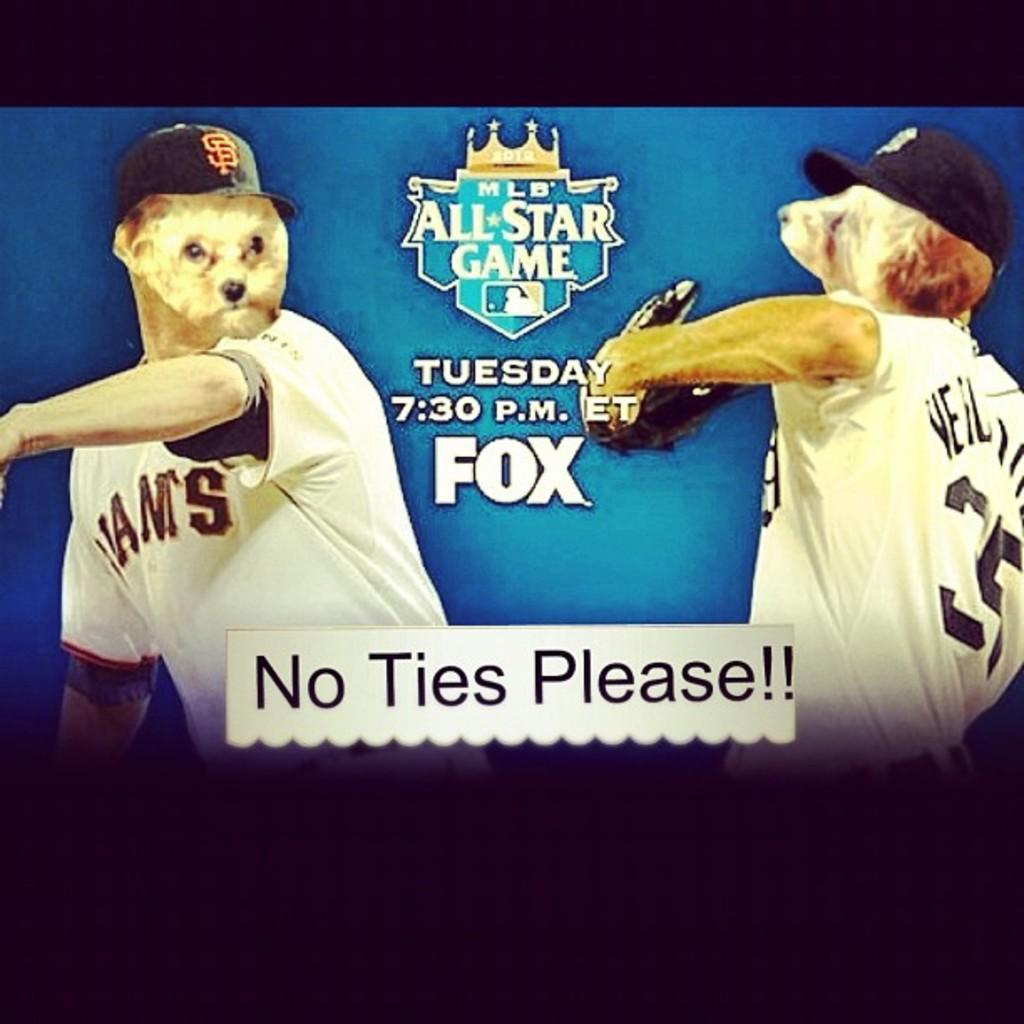<image>
Describe the image concisely. a no ties please line on the ad for the game 